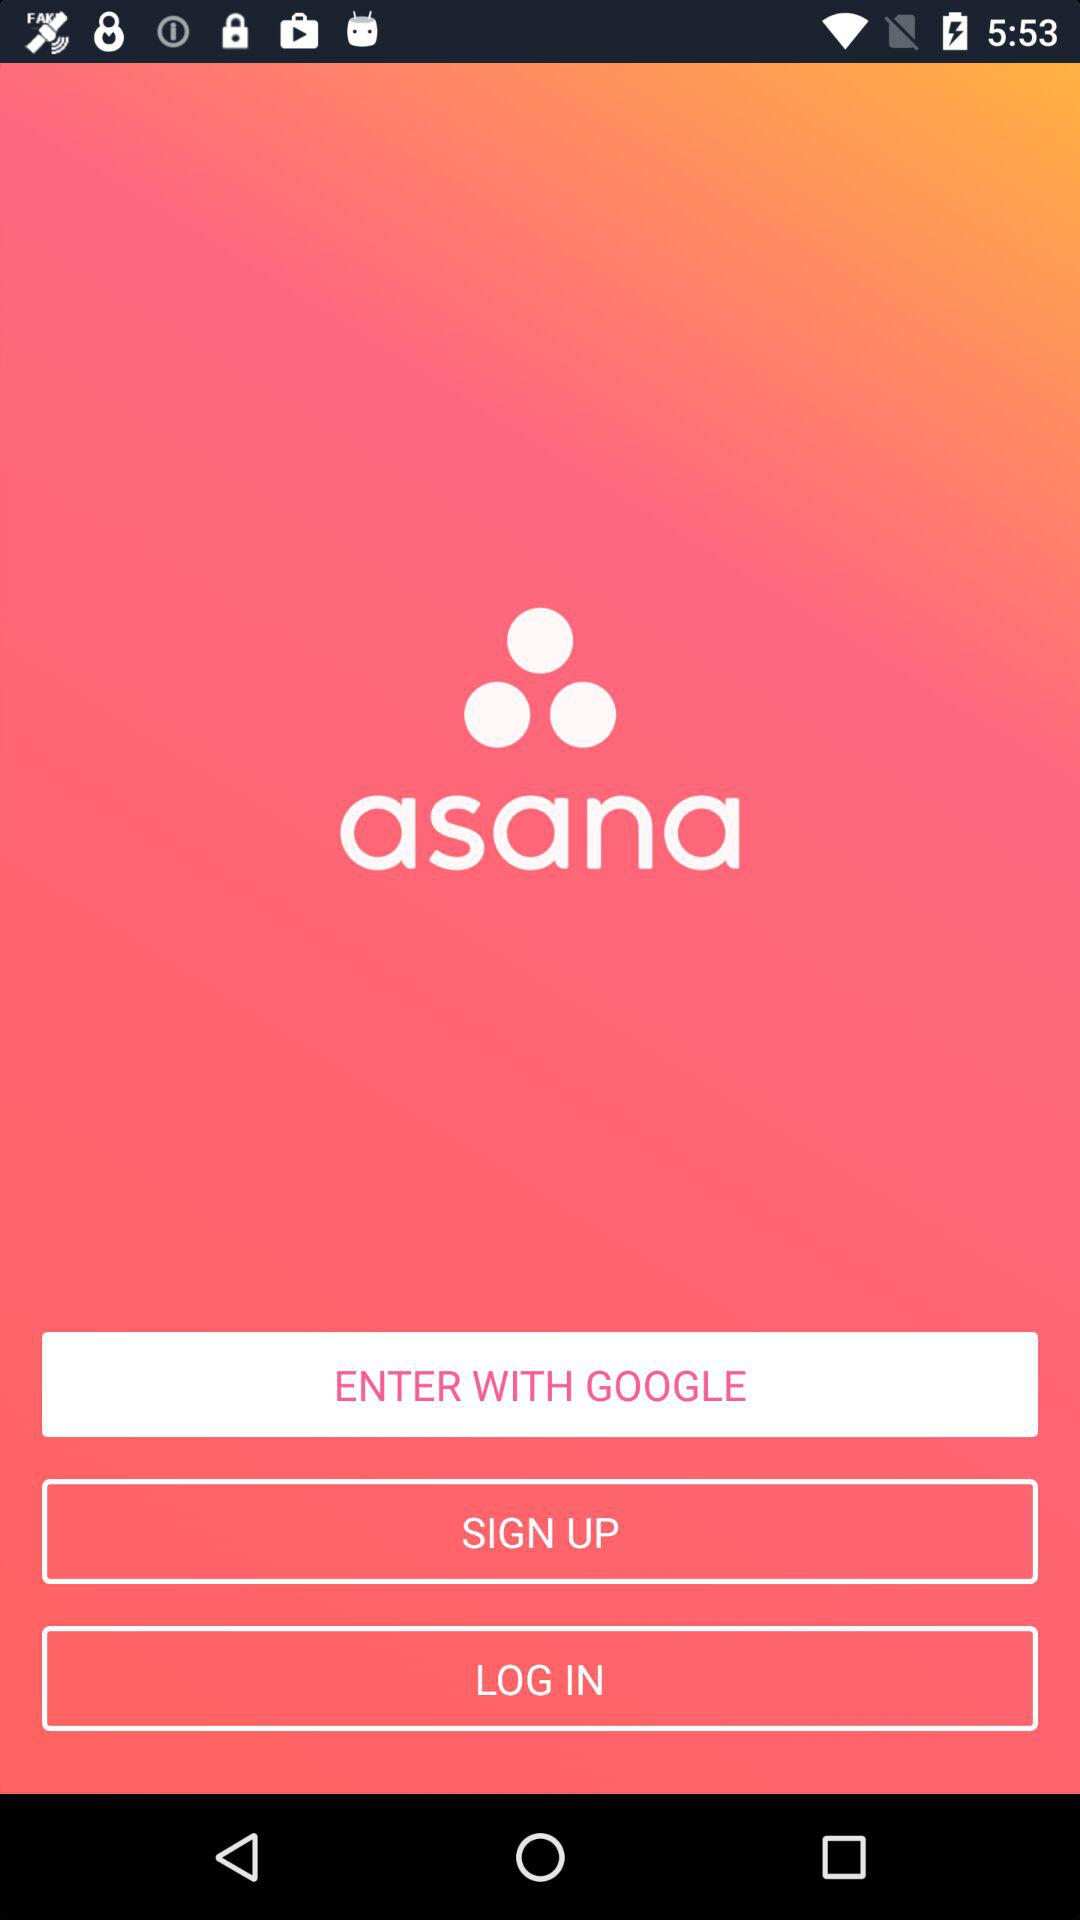What are the different options available for logging in? The different option available for logging in is "GOOGLE". 